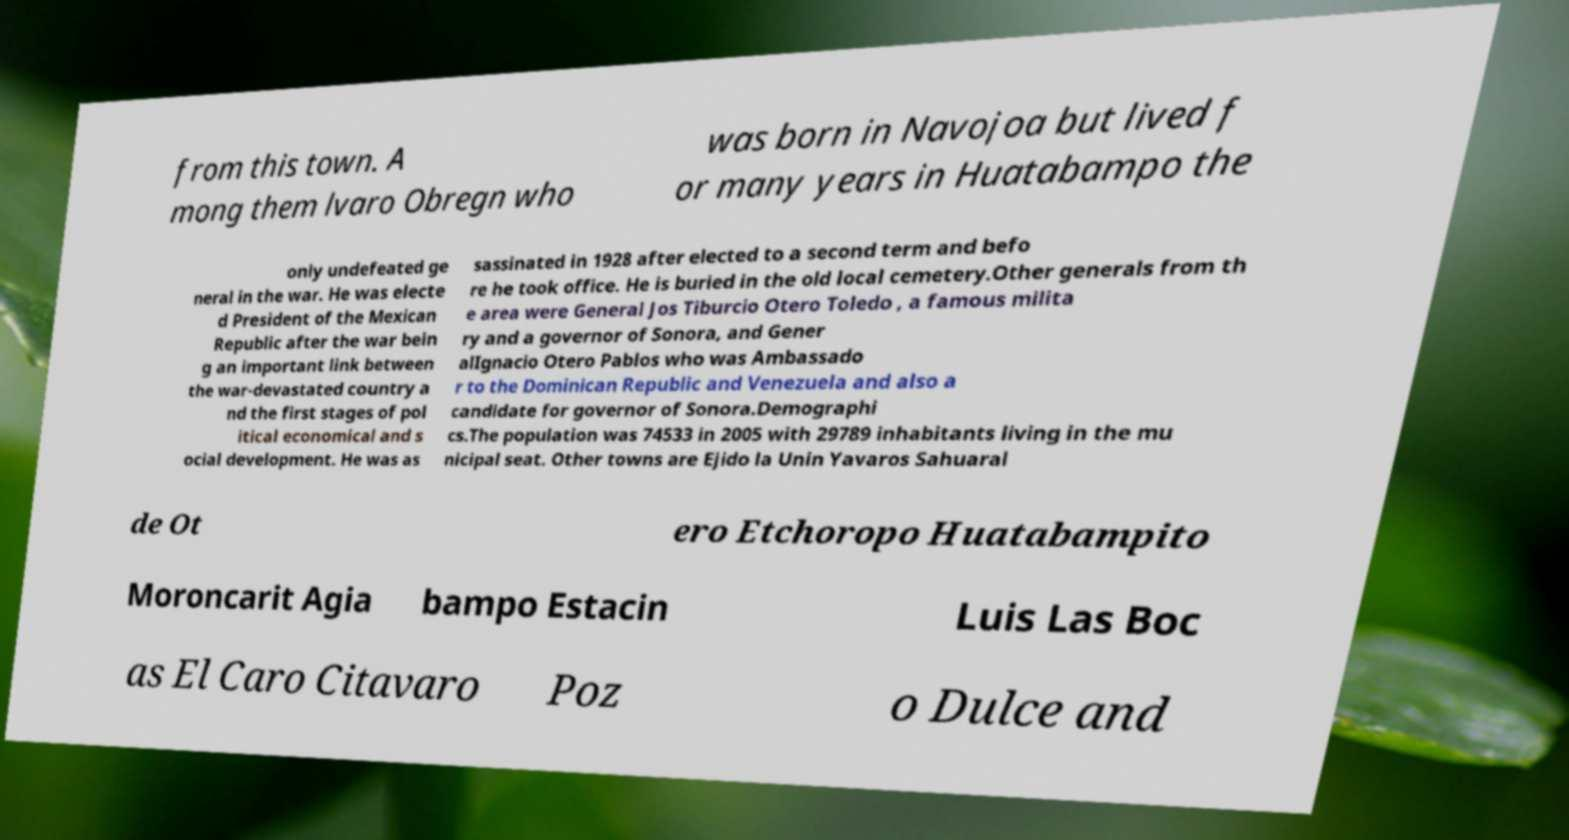Could you assist in decoding the text presented in this image and type it out clearly? from this town. A mong them lvaro Obregn who was born in Navojoa but lived f or many years in Huatabampo the only undefeated ge neral in the war. He was electe d President of the Mexican Republic after the war bein g an important link between the war-devastated country a nd the first stages of pol itical economical and s ocial development. He was as sassinated in 1928 after elected to a second term and befo re he took office. He is buried in the old local cemetery.Other generals from th e area were General Jos Tiburcio Otero Toledo , a famous milita ry and a governor of Sonora, and Gener alIgnacio Otero Pablos who was Ambassado r to the Dominican Republic and Venezuela and also a candidate for governor of Sonora.Demographi cs.The population was 74533 in 2005 with 29789 inhabitants living in the mu nicipal seat. Other towns are Ejido la Unin Yavaros Sahuaral de Ot ero Etchoropo Huatabampito Moroncarit Agia bampo Estacin Luis Las Boc as El Caro Citavaro Poz o Dulce and 